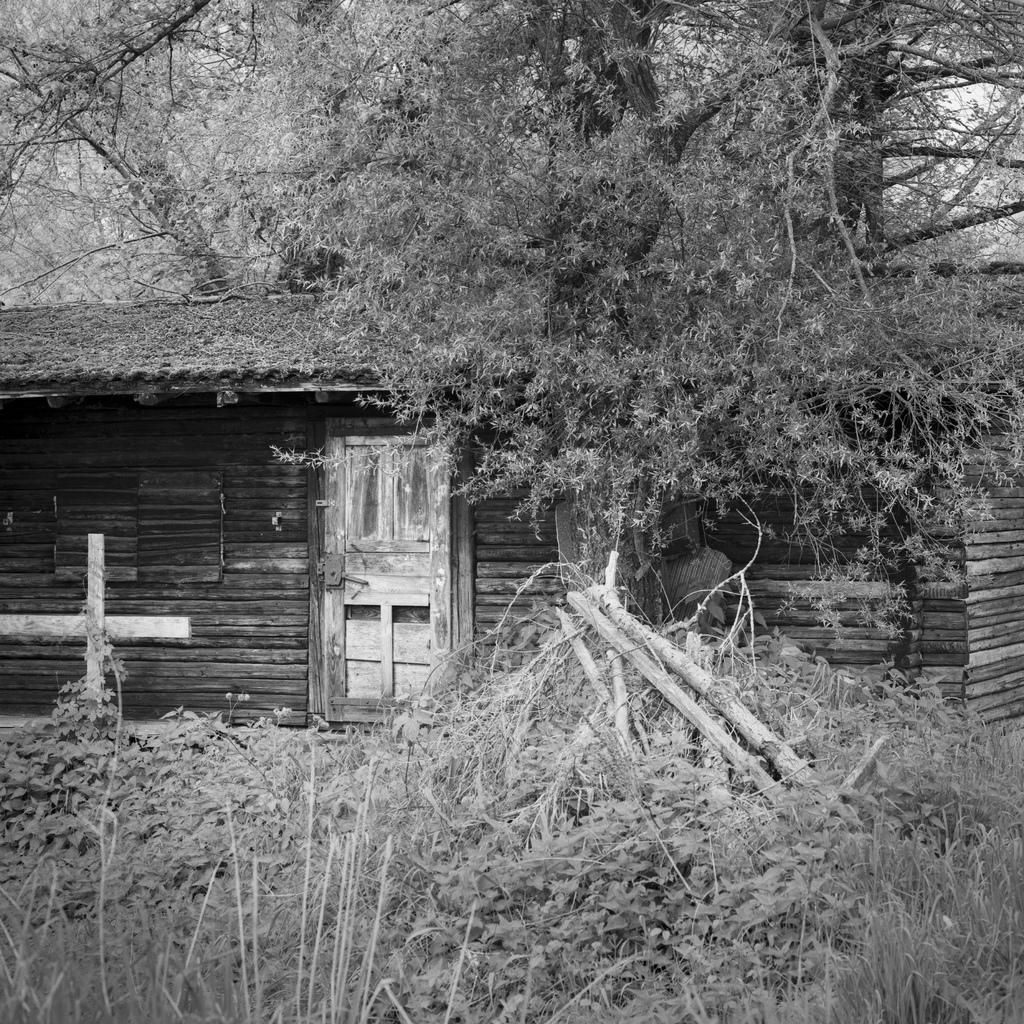Describe this image in one or two sentences. This is a black and white picture. Here we can see plants, trees, hut, and a door. 